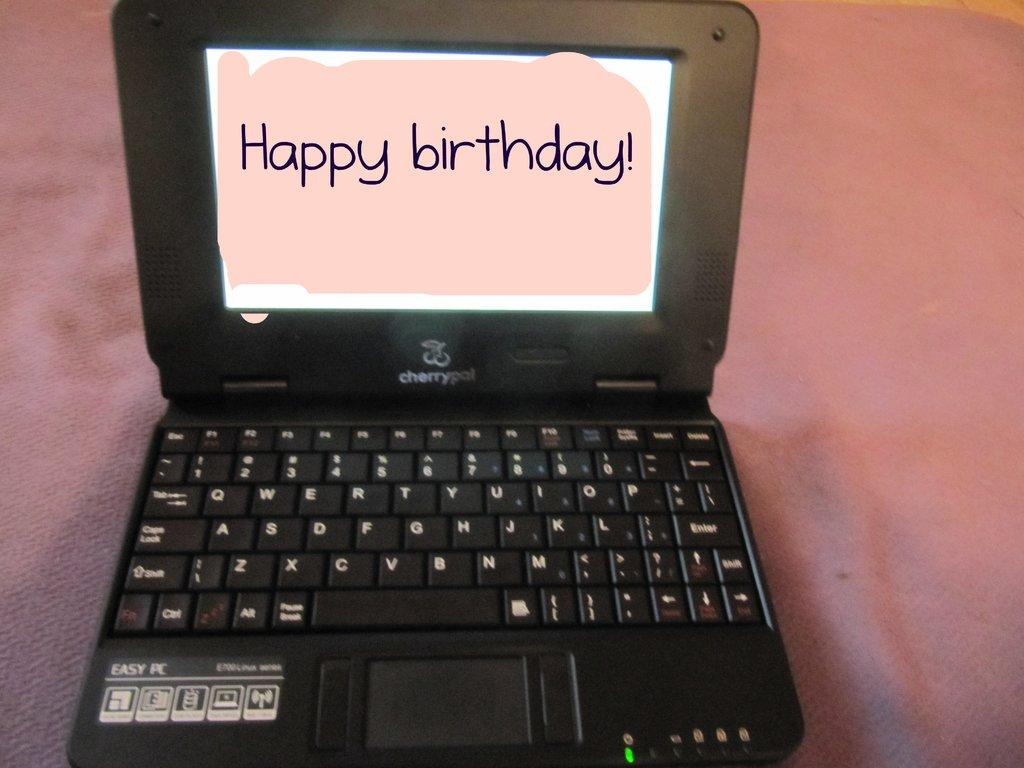Provide a one-sentence caption for the provided image. A laptop with the words displaying Happy Birthday covering the screen. 